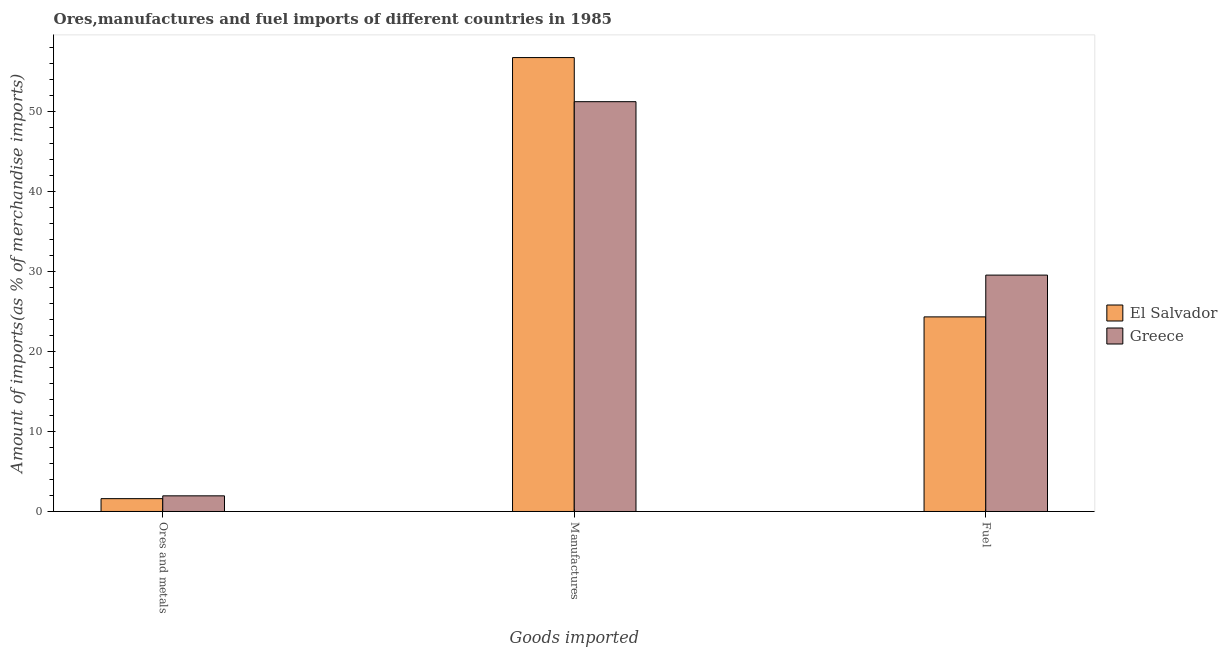How many groups of bars are there?
Provide a succinct answer. 3. Are the number of bars per tick equal to the number of legend labels?
Give a very brief answer. Yes. How many bars are there on the 2nd tick from the left?
Your answer should be compact. 2. How many bars are there on the 1st tick from the right?
Make the answer very short. 2. What is the label of the 3rd group of bars from the left?
Provide a short and direct response. Fuel. What is the percentage of manufactures imports in El Salvador?
Ensure brevity in your answer.  56.7. Across all countries, what is the maximum percentage of manufactures imports?
Your answer should be compact. 56.7. Across all countries, what is the minimum percentage of manufactures imports?
Give a very brief answer. 51.19. In which country was the percentage of manufactures imports maximum?
Provide a short and direct response. El Salvador. In which country was the percentage of manufactures imports minimum?
Offer a terse response. Greece. What is the total percentage of ores and metals imports in the graph?
Make the answer very short. 3.56. What is the difference between the percentage of fuel imports in Greece and that in El Salvador?
Keep it short and to the point. 5.22. What is the difference between the percentage of manufactures imports in El Salvador and the percentage of ores and metals imports in Greece?
Keep it short and to the point. 54.75. What is the average percentage of fuel imports per country?
Provide a succinct answer. 26.92. What is the difference between the percentage of ores and metals imports and percentage of manufactures imports in El Salvador?
Provide a short and direct response. -55.1. In how many countries, is the percentage of ores and metals imports greater than 44 %?
Provide a short and direct response. 0. What is the ratio of the percentage of ores and metals imports in Greece to that in El Salvador?
Offer a terse response. 1.22. What is the difference between the highest and the second highest percentage of fuel imports?
Offer a terse response. 5.22. What is the difference between the highest and the lowest percentage of fuel imports?
Make the answer very short. 5.22. Is the sum of the percentage of fuel imports in El Salvador and Greece greater than the maximum percentage of manufactures imports across all countries?
Keep it short and to the point. No. What does the 1st bar from the left in Fuel represents?
Offer a terse response. El Salvador. What does the 2nd bar from the right in Manufactures represents?
Keep it short and to the point. El Salvador. Is it the case that in every country, the sum of the percentage of ores and metals imports and percentage of manufactures imports is greater than the percentage of fuel imports?
Make the answer very short. Yes. How many bars are there?
Keep it short and to the point. 6. Are all the bars in the graph horizontal?
Offer a terse response. No. How many countries are there in the graph?
Provide a short and direct response. 2. How are the legend labels stacked?
Make the answer very short. Vertical. What is the title of the graph?
Ensure brevity in your answer.  Ores,manufactures and fuel imports of different countries in 1985. What is the label or title of the X-axis?
Your answer should be compact. Goods imported. What is the label or title of the Y-axis?
Offer a terse response. Amount of imports(as % of merchandise imports). What is the Amount of imports(as % of merchandise imports) in El Salvador in Ores and metals?
Ensure brevity in your answer.  1.6. What is the Amount of imports(as % of merchandise imports) of Greece in Ores and metals?
Give a very brief answer. 1.95. What is the Amount of imports(as % of merchandise imports) of El Salvador in Manufactures?
Your answer should be very brief. 56.7. What is the Amount of imports(as % of merchandise imports) of Greece in Manufactures?
Provide a short and direct response. 51.19. What is the Amount of imports(as % of merchandise imports) of El Salvador in Fuel?
Offer a very short reply. 24.31. What is the Amount of imports(as % of merchandise imports) in Greece in Fuel?
Make the answer very short. 29.53. Across all Goods imported, what is the maximum Amount of imports(as % of merchandise imports) of El Salvador?
Ensure brevity in your answer.  56.7. Across all Goods imported, what is the maximum Amount of imports(as % of merchandise imports) of Greece?
Your answer should be very brief. 51.19. Across all Goods imported, what is the minimum Amount of imports(as % of merchandise imports) of El Salvador?
Your response must be concise. 1.6. Across all Goods imported, what is the minimum Amount of imports(as % of merchandise imports) in Greece?
Make the answer very short. 1.95. What is the total Amount of imports(as % of merchandise imports) in El Salvador in the graph?
Your response must be concise. 82.61. What is the total Amount of imports(as % of merchandise imports) in Greece in the graph?
Keep it short and to the point. 82.67. What is the difference between the Amount of imports(as % of merchandise imports) in El Salvador in Ores and metals and that in Manufactures?
Provide a short and direct response. -55.1. What is the difference between the Amount of imports(as % of merchandise imports) in Greece in Ores and metals and that in Manufactures?
Give a very brief answer. -49.24. What is the difference between the Amount of imports(as % of merchandise imports) in El Salvador in Ores and metals and that in Fuel?
Ensure brevity in your answer.  -22.71. What is the difference between the Amount of imports(as % of merchandise imports) of Greece in Ores and metals and that in Fuel?
Offer a terse response. -27.57. What is the difference between the Amount of imports(as % of merchandise imports) of El Salvador in Manufactures and that in Fuel?
Keep it short and to the point. 32.39. What is the difference between the Amount of imports(as % of merchandise imports) of Greece in Manufactures and that in Fuel?
Offer a terse response. 21.66. What is the difference between the Amount of imports(as % of merchandise imports) of El Salvador in Ores and metals and the Amount of imports(as % of merchandise imports) of Greece in Manufactures?
Offer a terse response. -49.59. What is the difference between the Amount of imports(as % of merchandise imports) of El Salvador in Ores and metals and the Amount of imports(as % of merchandise imports) of Greece in Fuel?
Make the answer very short. -27.92. What is the difference between the Amount of imports(as % of merchandise imports) in El Salvador in Manufactures and the Amount of imports(as % of merchandise imports) in Greece in Fuel?
Ensure brevity in your answer.  27.17. What is the average Amount of imports(as % of merchandise imports) in El Salvador per Goods imported?
Keep it short and to the point. 27.54. What is the average Amount of imports(as % of merchandise imports) of Greece per Goods imported?
Give a very brief answer. 27.56. What is the difference between the Amount of imports(as % of merchandise imports) in El Salvador and Amount of imports(as % of merchandise imports) in Greece in Ores and metals?
Give a very brief answer. -0.35. What is the difference between the Amount of imports(as % of merchandise imports) of El Salvador and Amount of imports(as % of merchandise imports) of Greece in Manufactures?
Your answer should be compact. 5.51. What is the difference between the Amount of imports(as % of merchandise imports) of El Salvador and Amount of imports(as % of merchandise imports) of Greece in Fuel?
Offer a very short reply. -5.22. What is the ratio of the Amount of imports(as % of merchandise imports) of El Salvador in Ores and metals to that in Manufactures?
Give a very brief answer. 0.03. What is the ratio of the Amount of imports(as % of merchandise imports) in Greece in Ores and metals to that in Manufactures?
Your answer should be compact. 0.04. What is the ratio of the Amount of imports(as % of merchandise imports) in El Salvador in Ores and metals to that in Fuel?
Provide a short and direct response. 0.07. What is the ratio of the Amount of imports(as % of merchandise imports) of Greece in Ores and metals to that in Fuel?
Provide a short and direct response. 0.07. What is the ratio of the Amount of imports(as % of merchandise imports) in El Salvador in Manufactures to that in Fuel?
Make the answer very short. 2.33. What is the ratio of the Amount of imports(as % of merchandise imports) of Greece in Manufactures to that in Fuel?
Give a very brief answer. 1.73. What is the difference between the highest and the second highest Amount of imports(as % of merchandise imports) in El Salvador?
Your response must be concise. 32.39. What is the difference between the highest and the second highest Amount of imports(as % of merchandise imports) in Greece?
Your answer should be compact. 21.66. What is the difference between the highest and the lowest Amount of imports(as % of merchandise imports) of El Salvador?
Make the answer very short. 55.1. What is the difference between the highest and the lowest Amount of imports(as % of merchandise imports) of Greece?
Give a very brief answer. 49.24. 